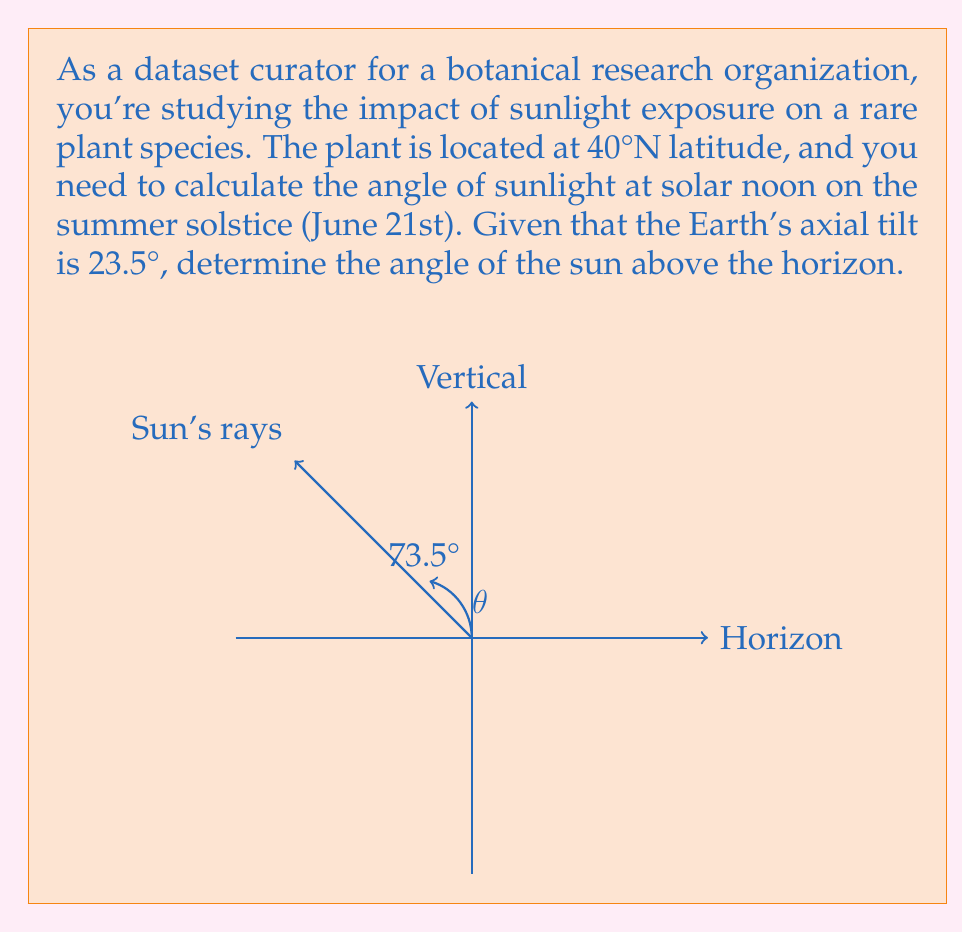Teach me how to tackle this problem. To solve this problem, we'll follow these steps:

1) The angle of the sun above the horizon at solar noon is complementary to the latitude's angular distance from the sun's declination.

2) On the summer solstice, the sun's declination is equal to the Earth's axial tilt: 23.5°.

3) The latitude of the location is 40°N.

4) We can calculate the angular distance from the sun's declination to the latitude:
   $40° - 23.5° = 16.5°$

5) The angle of the sun above the horizon ($θ$) is complementary to this angular distance:
   $θ = 90° - 16.5° = 73.5°$

6) We can verify this using the equation:
   $θ = 90° - |latitude - declination|$
   $θ = 90° - |40° - 23.5°| = 90° - 16.5° = 73.5°$

Therefore, on the summer solstice at solar noon, the sun will be 73.5° above the horizon at this location.
Answer: $73.5°$ 